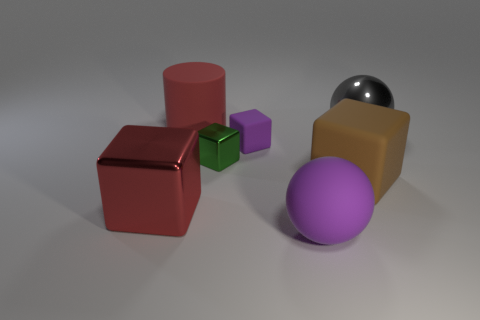Subtract all balls. How many objects are left? 5 Subtract 4 blocks. How many blocks are left? 0 Subtract all cyan cylinders. Subtract all gray blocks. How many cylinders are left? 1 Subtract all yellow spheres. How many brown blocks are left? 1 Subtract all large cyan things. Subtract all big objects. How many objects are left? 2 Add 7 green cubes. How many green cubes are left? 8 Add 7 big blue matte cylinders. How many big blue matte cylinders exist? 7 Add 1 large gray shiny things. How many objects exist? 8 Subtract all brown blocks. How many blocks are left? 3 Subtract all big red shiny blocks. How many blocks are left? 3 